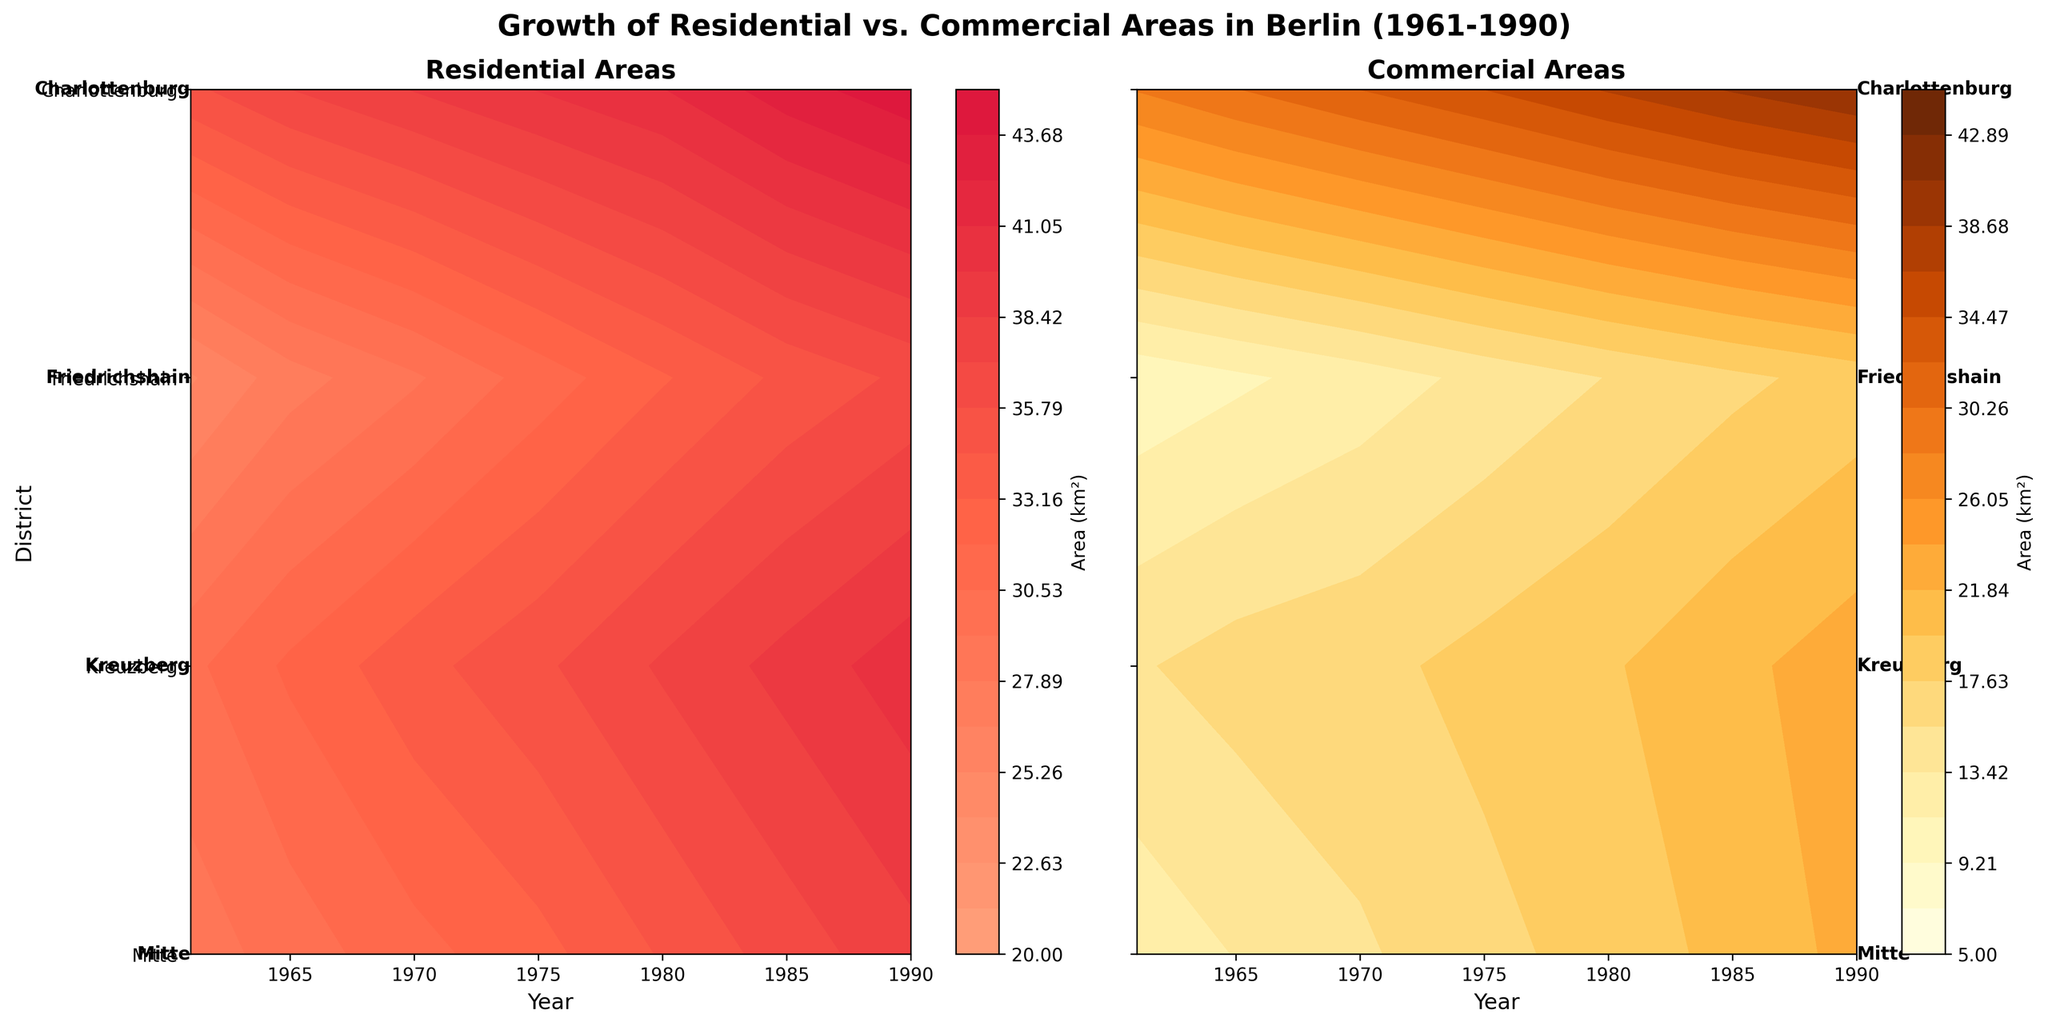What is the title of the figure? The title is usually placed at the top of the figure and provides a brief summary of what the figure represents.
Answer: Growth of Residential vs. Commercial Areas in Berlin (1961-1990) What are the colors used for the residential and commercial area contour plots? Residential areas use a gradient from light salmon to crimson, while commercial areas use shades of yellow to brown, indicating different data points on the plots.
Answer: Residential: light salmon to crimson, Commercial: yellow to brown Which district shows the highest residential area growth in 1990? The residential contour plot will show the highest value in 1990 under one of the districts. By looking at the highest point in the 1990 vertical line, one can identify the district.
Answer: Charlottenburg Which district had the lowest commercial area value in 1961? By examining the commercial contour plot and looking at the values under the 1961 line, we can determine which district has the smallest value.
Answer: Friedrichshain How do the residential and commercial areas in Charlottenburg compare in 1980? Look at both contour plots for the year 1980 under the district Charlottenburg. Identify the values and compare them.
Answer: Residential: ~41 km², Commercial: ~36.8 km² Which district had the largest increase in residential area from 1961 to 1990? To determine this, look at the residential area values for 1961 and 1990 for all districts and calculate the increase for each district.
Answer: Charlottenburg Between 1965 and 1970, which district saw the largest increase in commercial area? By comparing the commercial area values in 1965 and 1970 for each district, find the district with the largest increment.
Answer: Charlottenburg In 1975, how does Kreuzberg's residential area compare to Friedrichshain's? Check the residential contour plot for the year 1975 and compare the values of Kreuzberg and Friedrichshain.
Answer: Kreuzberg: ~35.5 km², Friedrichshain: ~31.1 km² Which district saw the smallest change in commercial area from 1980 to 1990? Calculate the change in commercial area from 1980 to 1990 for each district and determine which one has the smallest difference.
Answer: Kreuzberg 